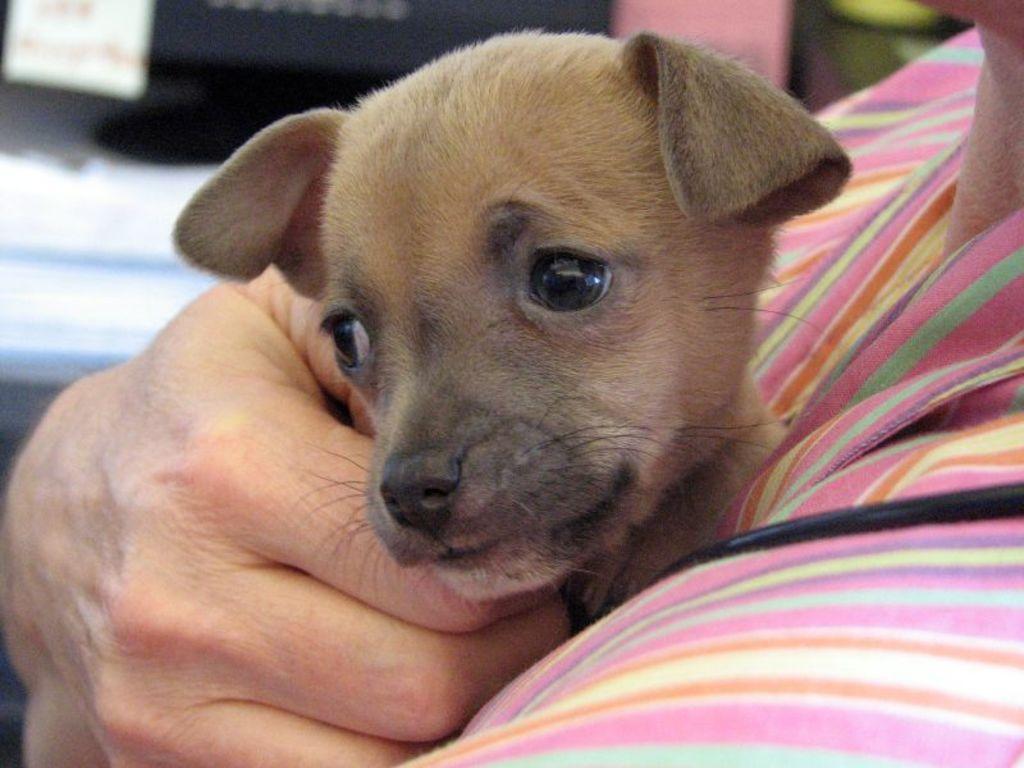How would you summarize this image in a sentence or two? In this image I can see a person holding an animal. 